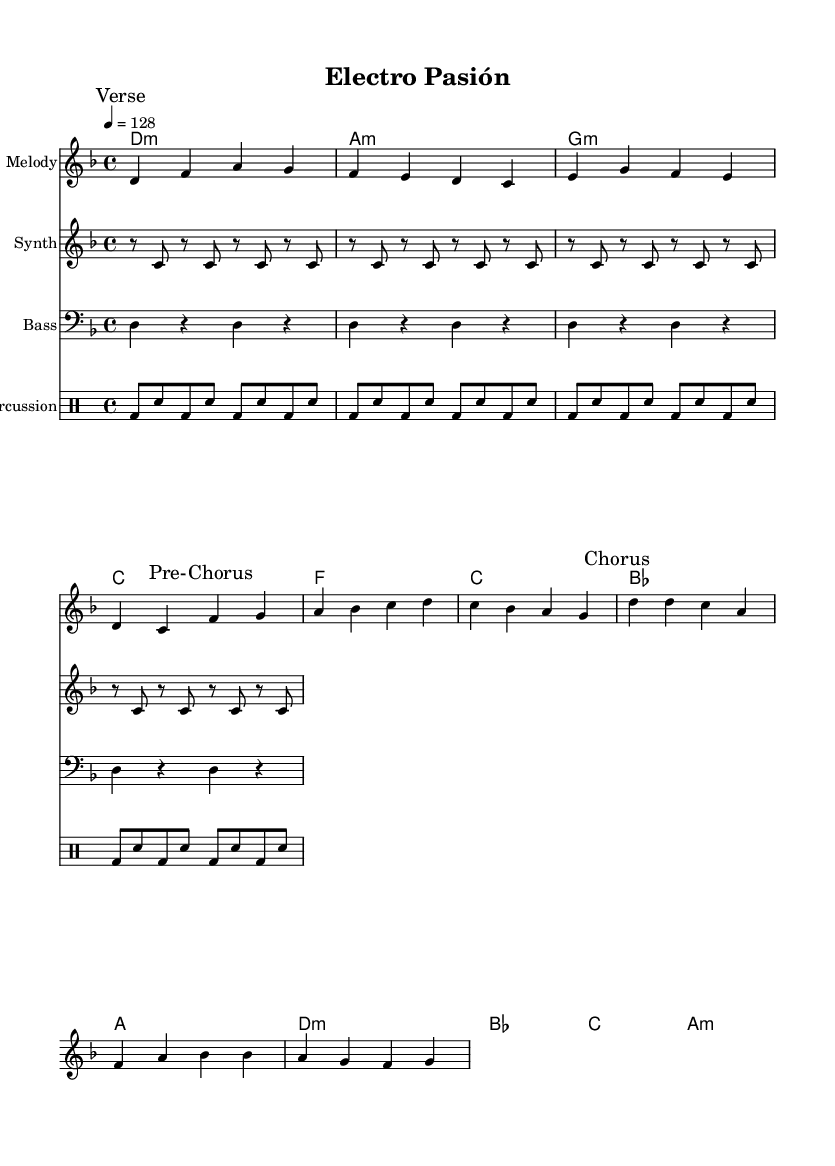What is the key signature of this music? The key signature, indicated at the beginning of the score, is D minor, which has one flat (B flat).
Answer: D minor What is the time signature of this music? The time signature is noted at the start of the score, showing 4/4, which means there are four beats in a measure.
Answer: 4/4 What is the tempo marking for this piece? The tempo is indicated in beats per minute, set as 128, showing the speed at which the music should be played.
Answer: 128 How many measures are in the melody section? Counting the measures in the melody part labeled "Verse,” "Pre-Chorus," and "Chorus," there are a total of 10 measures.
Answer: 10 What type of chords are predominantly used in this piece? The harmony section shows the use of minor chords (indicated by "m" for minor) such as D minor, A minor, and G minor, which are commonly found in Latin-electronic fusion music.
Answer: Minor How does the rhythm of the bass contribute to the overall feel of the piece? The bass uses a repetitive rhythm (alternating between the note D and rests), contributing to a steady pulse typical in electronic and dance music, enhancing the groove of the piece.
Answer: Steady pulse What vocal style is implied by the song structure in this music? The structure includes marked sections that imply dramatic vocal performances characterized by dynamic contrasts, often seen in Latin-electronic fusion genres.
Answer: Dramatic 